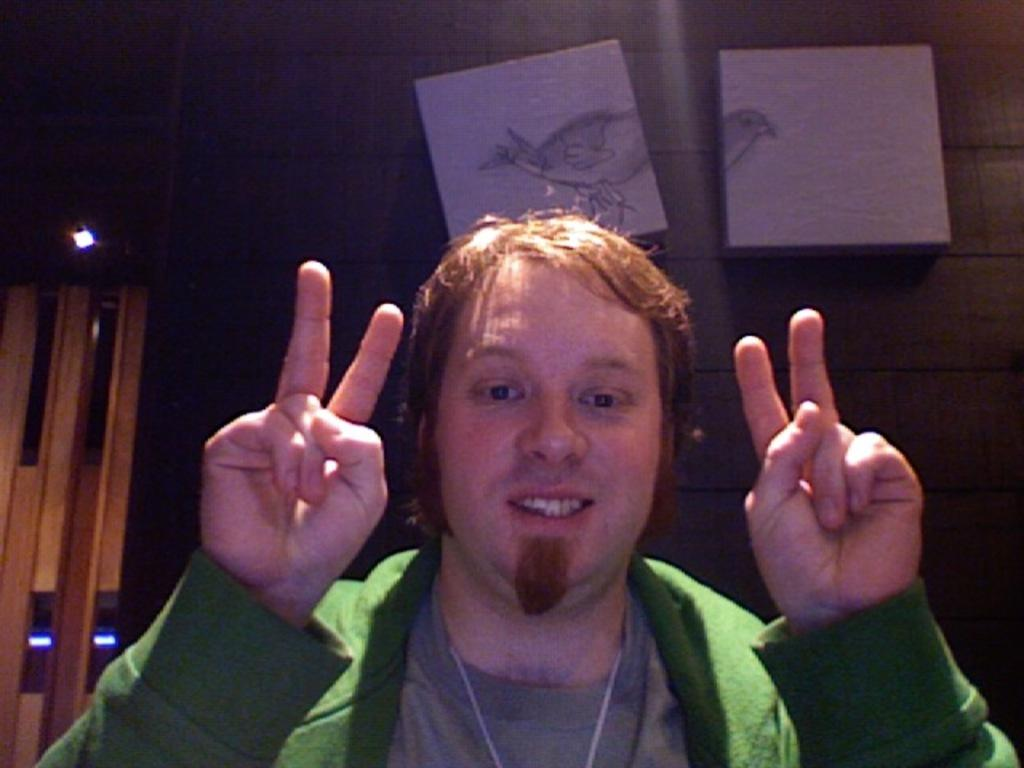Who or what is present in the image? There is a person in the image. What can be seen on the wall in the image? There are objects on the wall in the image. Where are the lights located in the image? The lights are on the left side of the image. What type of pipe is being used for reading in the image? There is no pipe or reading material present in the image. 